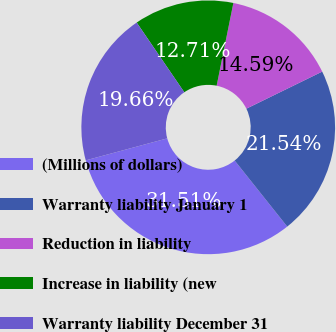Convert chart. <chart><loc_0><loc_0><loc_500><loc_500><pie_chart><fcel>(Millions of dollars)<fcel>Warranty liability January 1<fcel>Reduction in liability<fcel>Increase in liability (new<fcel>Warranty liability December 31<nl><fcel>31.51%<fcel>21.54%<fcel>14.59%<fcel>12.71%<fcel>19.66%<nl></chart> 